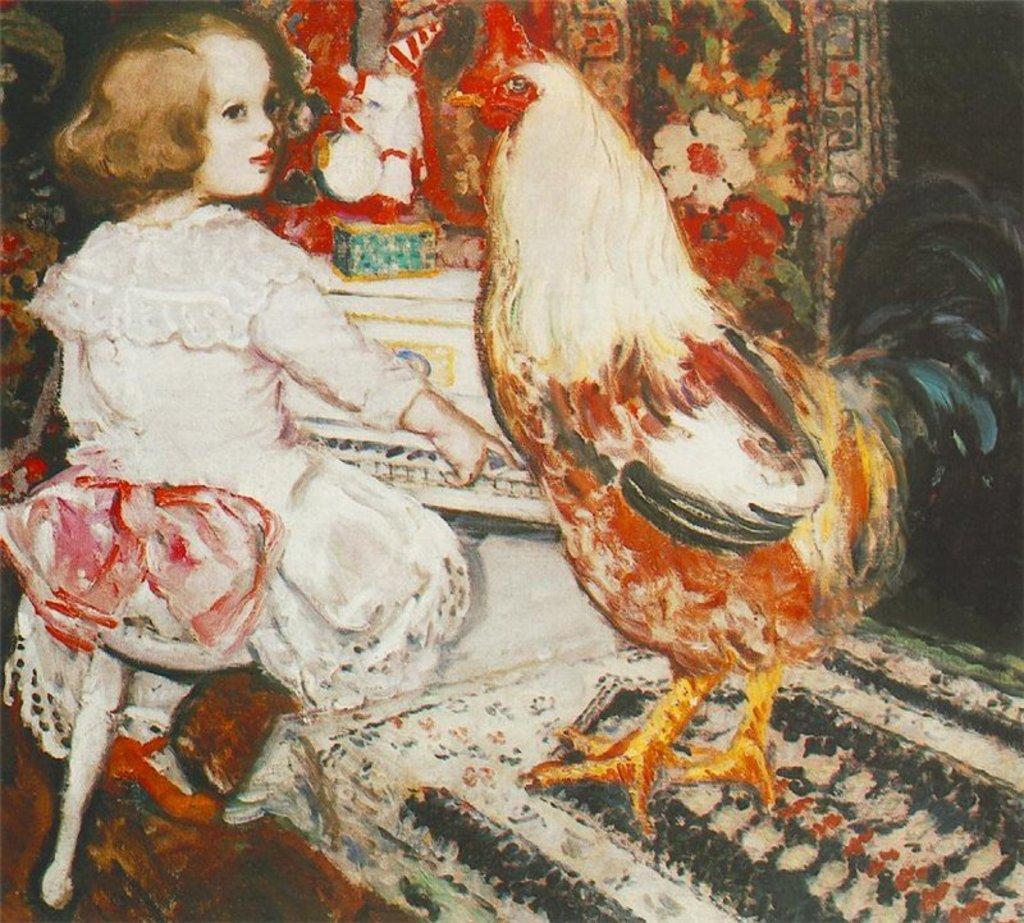Could you give a brief overview of what you see in this image? In this picture we can see a painting where a girl is sitting on the chair near a table with a cock standing on it. In the background we have flowers & a table. 